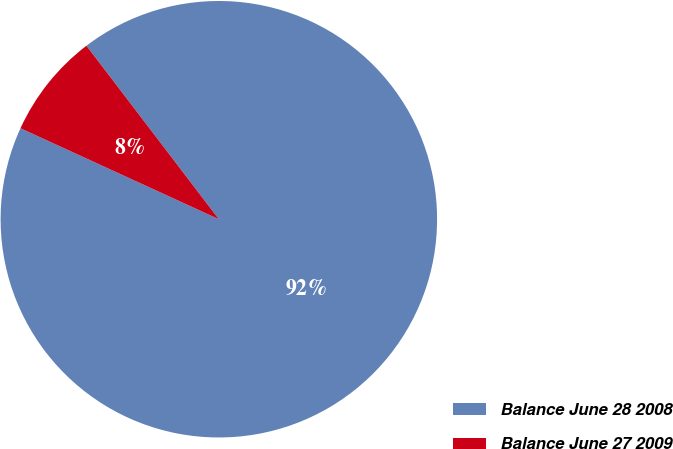<chart> <loc_0><loc_0><loc_500><loc_500><pie_chart><fcel>Balance June 28 2008<fcel>Balance June 27 2009<nl><fcel>92.22%<fcel>7.78%<nl></chart> 